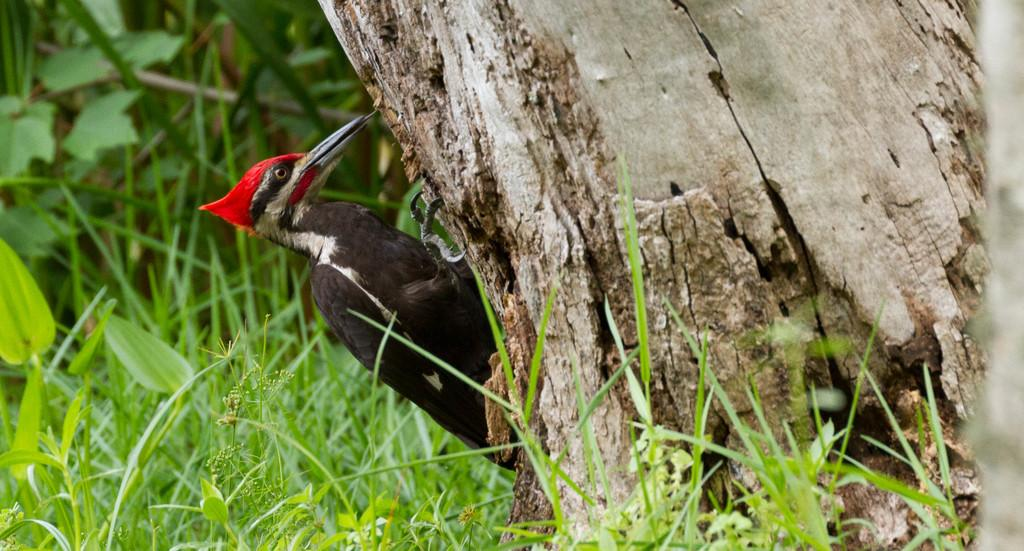What type of bird is in the image? There is a woodpecker in the image. Where is the woodpecker located? The woodpecker is on a tree. Can you describe the tree in the image? The tree appears to be truncated. What other types of vegetation can be seen in the image? There are plants and grass visible in the image. Where are the plants located in the image? The plants are on the ground on the left side of the image. What type of airport can be seen in the image? There is no airport present in the image; it features a woodpecker on a tree. What type of garden is visible in the image? There is no garden present in the image; it features a woodpecker on a tree and other vegetation. 